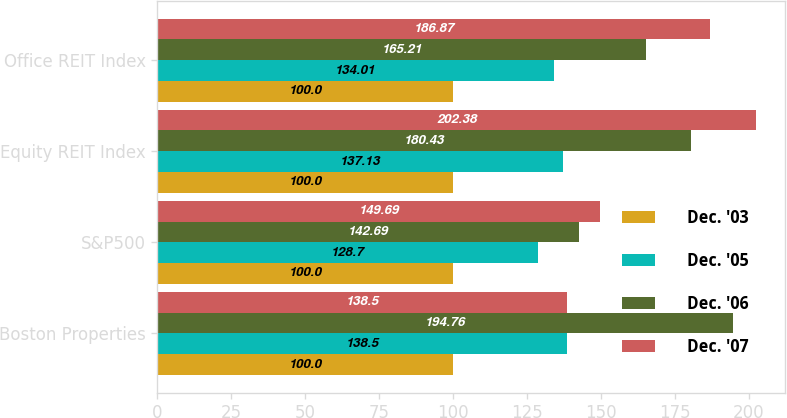<chart> <loc_0><loc_0><loc_500><loc_500><stacked_bar_chart><ecel><fcel>Boston Properties<fcel>S&P500<fcel>Equity REIT Index<fcel>Office REIT Index<nl><fcel>Dec. '03<fcel>100<fcel>100<fcel>100<fcel>100<nl><fcel>Dec. '05<fcel>138.5<fcel>128.7<fcel>137.13<fcel>134.01<nl><fcel>Dec. '06<fcel>194.76<fcel>142.69<fcel>180.43<fcel>165.21<nl><fcel>Dec. '07<fcel>138.5<fcel>149.69<fcel>202.38<fcel>186.87<nl></chart> 